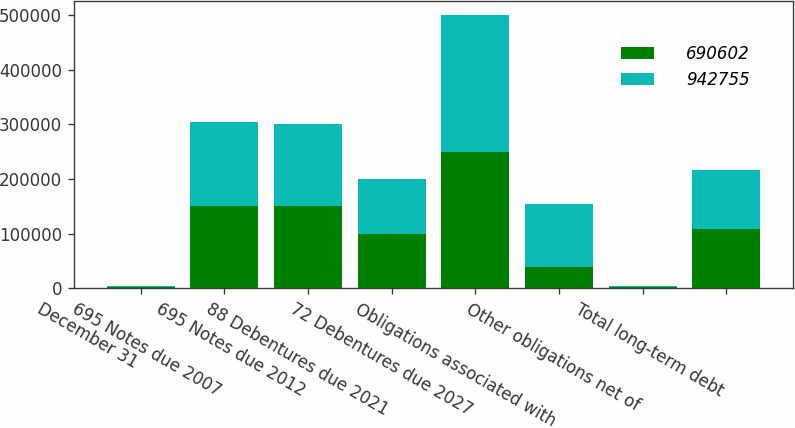Convert chart. <chart><loc_0><loc_0><loc_500><loc_500><stacked_bar_chart><ecel><fcel>December 31<fcel>695 Notes due 2007<fcel>695 Notes due 2012<fcel>88 Debentures due 2021<fcel>72 Debentures due 2027<fcel>Obligations associated with<fcel>Other obligations net of<fcel>Total long-term debt<nl><fcel>690602<fcel>2005<fcel>151176<fcel>150000<fcel>100000<fcel>250000<fcel>38680<fcel>2955<fcel>107772<nl><fcel>942755<fcel>2004<fcel>152184<fcel>150000<fcel>100000<fcel>250000<fcel>115544<fcel>730<fcel>107772<nl></chart> 